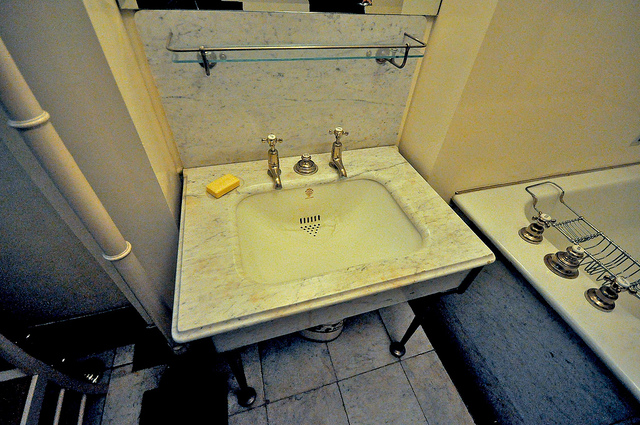What are the main objects you see in the image? In the image, the main objects include a marble sink with metal fixtures, a piece of yellow soap placed beside the sink, and a bathtub with metal fixtures. Additionally, there is a vertical pipe on the left side of the sink and a storage or shelf unit adjacent to the bathtub. 